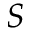<formula> <loc_0><loc_0><loc_500><loc_500>S</formula> 